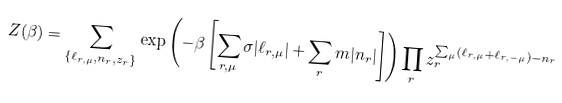Convert formula to latex. <formula><loc_0><loc_0><loc_500><loc_500>Z ( \beta ) = \sum _ { \{ \ell _ { r , \mu } , n _ { r } , z _ { r } \} } \exp \left ( - \beta \left [ \sum _ { r , \mu } \sigma | \ell _ { r , \mu } | + \sum _ { r } m | n _ { r } | \right ] \right ) \prod _ { r } z _ { r } ^ { \sum _ { \mu } ( \ell _ { r , \mu } + \ell _ { r , - \mu } ) - n _ { r } }</formula> 